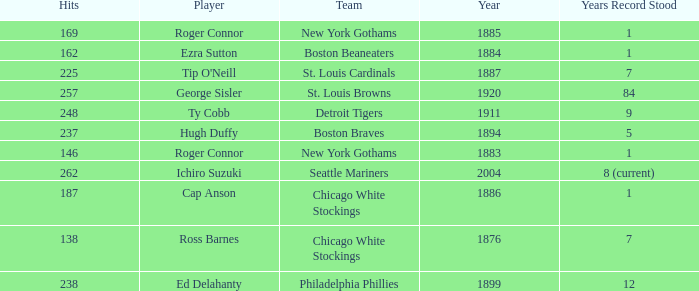Name the hits for years before 1883 138.0. 